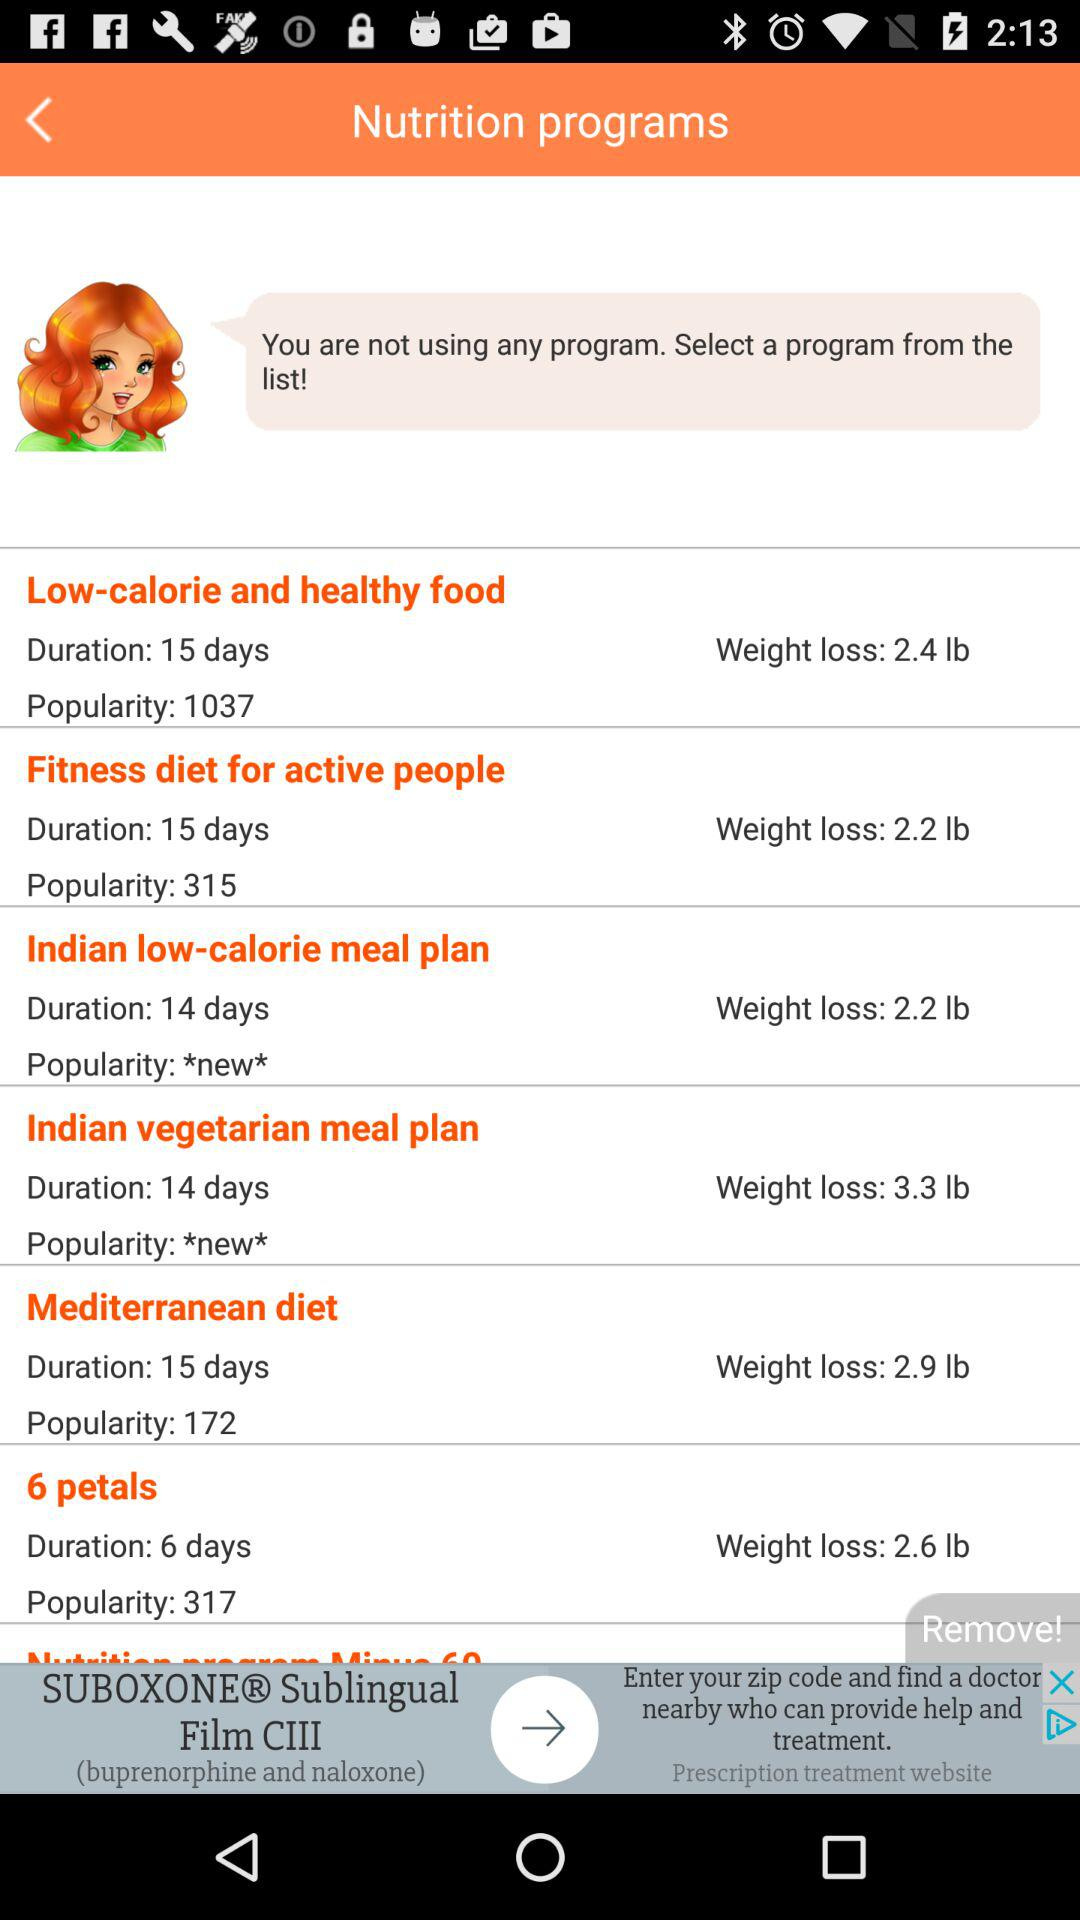What is the duration of the "Low-calorie and healthy food" program? The duration of the "Low-calorie and healthy food" program is 15 days. 